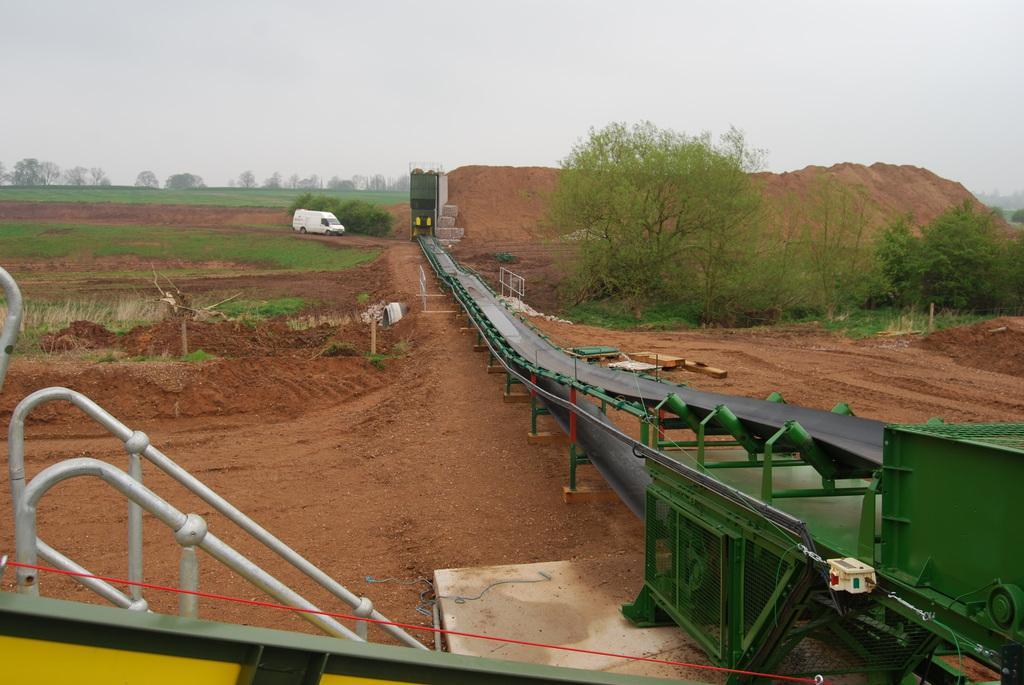How would you summarize this image in a sentence or two? This picture shows grass on the ground and we see trees and a vehicle. we see a machine and a cloudy sky. 